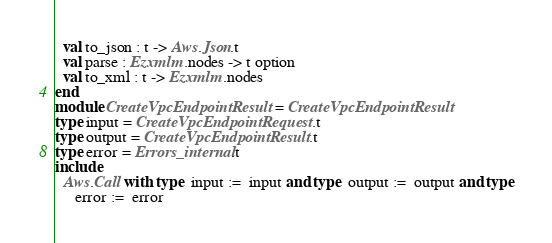<code> <loc_0><loc_0><loc_500><loc_500><_OCaml_>  val to_json : t -> Aws.Json.t
  val parse : Ezxmlm.nodes -> t option
  val to_xml : t -> Ezxmlm.nodes
end
module CreateVpcEndpointResult = CreateVpcEndpointResult
type input = CreateVpcEndpointRequest.t
type output = CreateVpcEndpointResult.t
type error = Errors_internal.t
include
  Aws.Call with type  input :=  input and type  output :=  output and type
     error :=  error</code> 